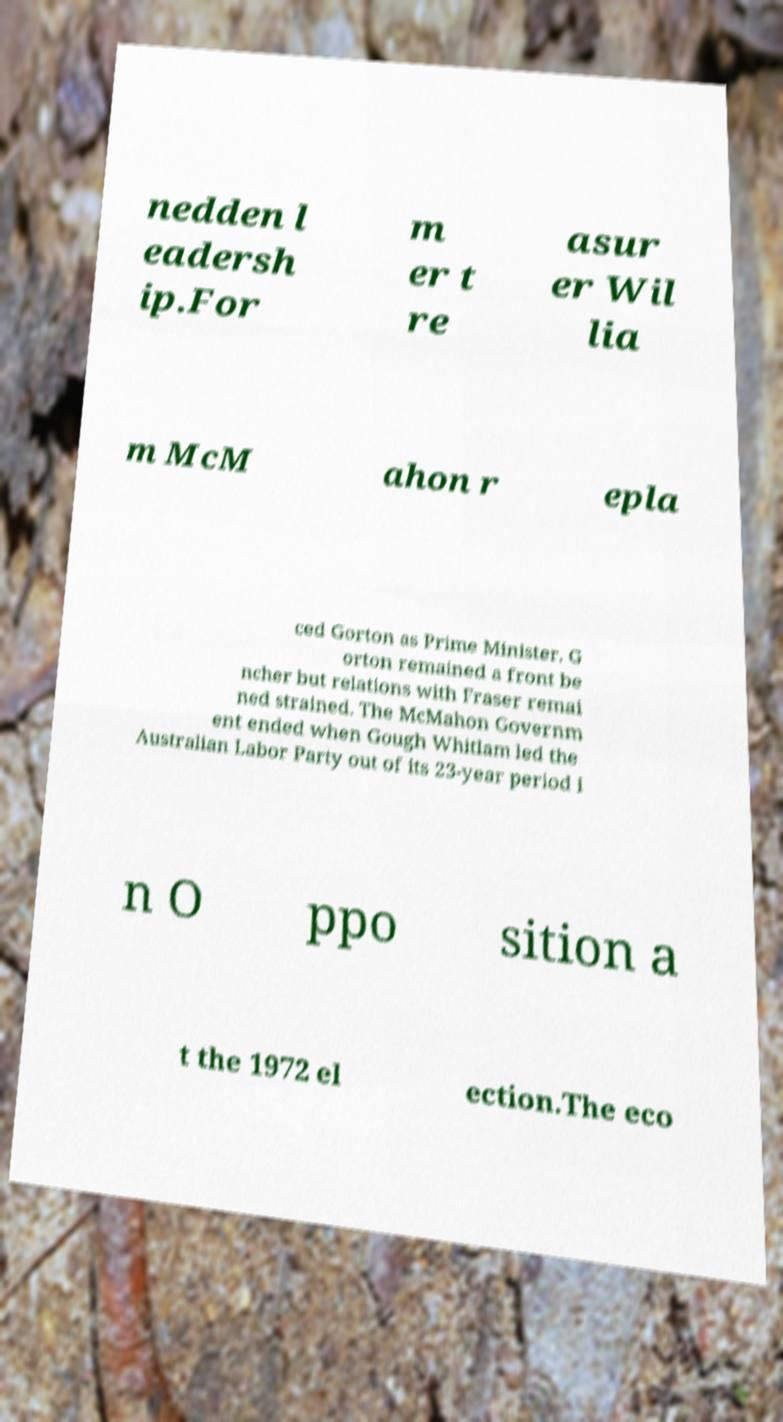Please read and relay the text visible in this image. What does it say? nedden l eadersh ip.For m er t re asur er Wil lia m McM ahon r epla ced Gorton as Prime Minister. G orton remained a front be ncher but relations with Fraser remai ned strained. The McMahon Governm ent ended when Gough Whitlam led the Australian Labor Party out of its 23-year period i n O ppo sition a t the 1972 el ection.The eco 